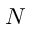<formula> <loc_0><loc_0><loc_500><loc_500>N</formula> 